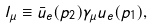Convert formula to latex. <formula><loc_0><loc_0><loc_500><loc_500>l _ { \mu } \equiv \bar { u } _ { e } ( p _ { 2 } ) \gamma _ { \mu } u _ { e } ( p _ { 1 } ) ,</formula> 